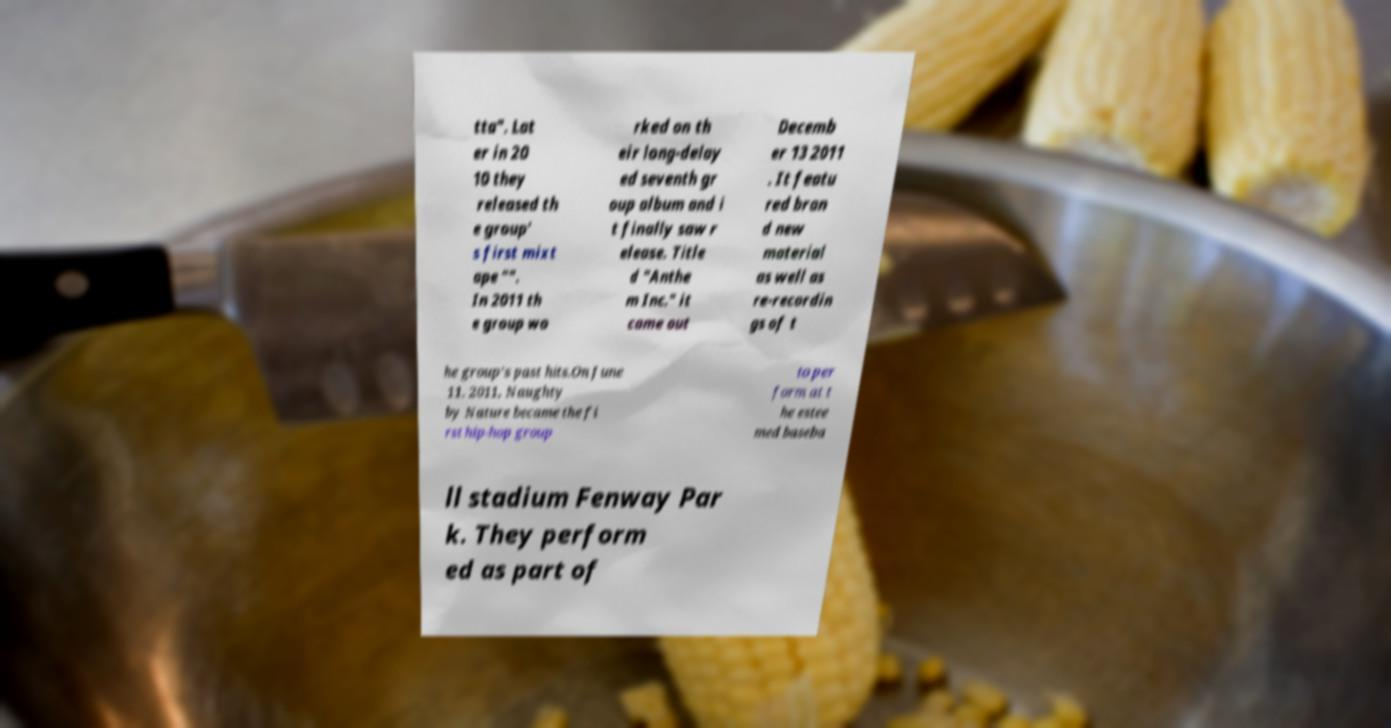I need the written content from this picture converted into text. Can you do that? tta". Lat er in 20 10 they released th e group' s first mixt ape "". In 2011 th e group wo rked on th eir long-delay ed seventh gr oup album and i t finally saw r elease. Title d "Anthe m Inc." it came out Decemb er 13 2011 . It featu red bran d new material as well as re-recordin gs of t he group's past hits.On June 11, 2011, Naughty by Nature became the fi rst hip-hop group to per form at t he estee med baseba ll stadium Fenway Par k. They perform ed as part of 